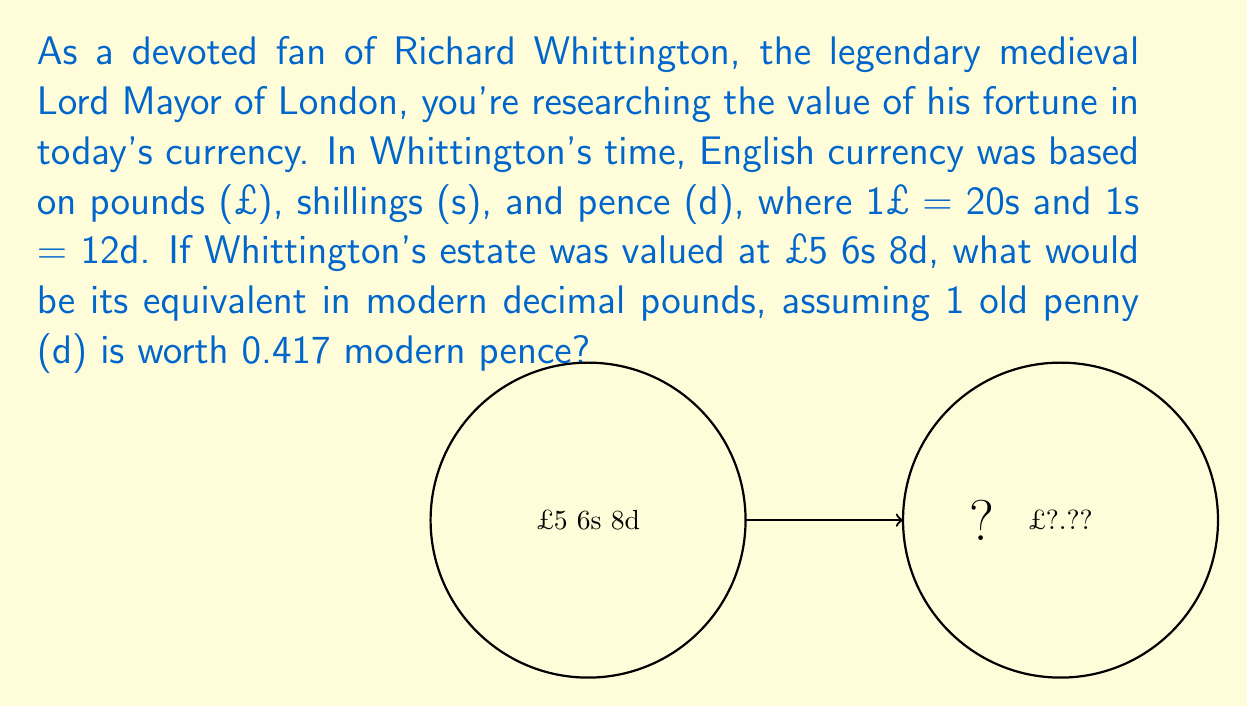Provide a solution to this math problem. To convert medieval English currency to the modern decimal system, we'll follow these steps:

1) First, convert everything to pence (d):
   £5 = 5 × 20 × 12d = 1200d
   6s = 6 × 12d = 72d
   8d = 8d
   Total = 1200d + 72d + 8d = 1280d

2) Now, convert old pence to modern pence:
   1280d × 0.417 = 533.76 modern pence

3) Convert modern pence to pounds:
   533.76 ÷ 100 = £5.3376

4) Round to two decimal places:
   £5.34 (rounded)

Therefore, Whittington's estate value of £5 6s 8d in medieval currency is equivalent to £5.34 in modern decimal currency.

The calculation can be represented as:

$$\frac{(5 \times 20 \times 12 + 6 \times 12 + 8) \times 0.417}{100} = 5.3376$$

Rounded to two decimal places: £5.34
Answer: £5.34 